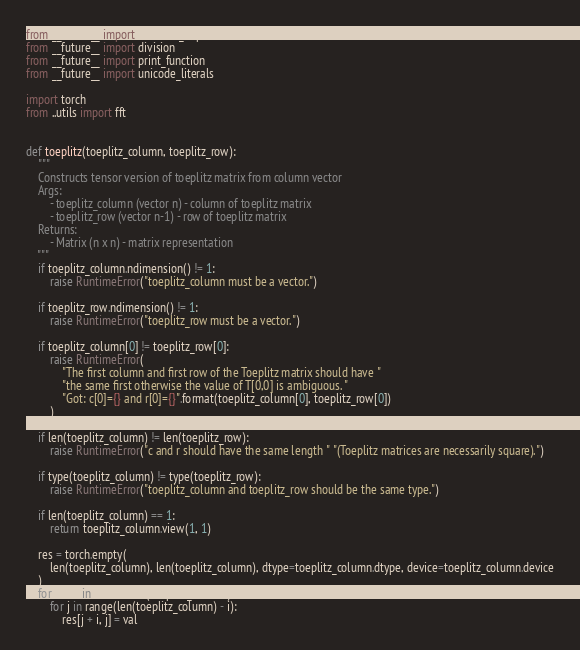<code> <loc_0><loc_0><loc_500><loc_500><_Python_>from __future__ import absolute_import
from __future__ import division
from __future__ import print_function
from __future__ import unicode_literals

import torch
from ..utils import fft


def toeplitz(toeplitz_column, toeplitz_row):
    """
    Constructs tensor version of toeplitz matrix from column vector
    Args:
        - toeplitz_column (vector n) - column of toeplitz matrix
        - toeplitz_row (vector n-1) - row of toeplitz matrix
    Returns:
        - Matrix (n x n) - matrix representation
    """
    if toeplitz_column.ndimension() != 1:
        raise RuntimeError("toeplitz_column must be a vector.")

    if toeplitz_row.ndimension() != 1:
        raise RuntimeError("toeplitz_row must be a vector.")

    if toeplitz_column[0] != toeplitz_row[0]:
        raise RuntimeError(
            "The first column and first row of the Toeplitz matrix should have "
            "the same first otherwise the value of T[0,0] is ambiguous. "
            "Got: c[0]={} and r[0]={}".format(toeplitz_column[0], toeplitz_row[0])
        )

    if len(toeplitz_column) != len(toeplitz_row):
        raise RuntimeError("c and r should have the same length " "(Toeplitz matrices are necessarily square).")

    if type(toeplitz_column) != type(toeplitz_row):
        raise RuntimeError("toeplitz_column and toeplitz_row should be the same type.")

    if len(toeplitz_column) == 1:
        return toeplitz_column.view(1, 1)

    res = torch.empty(
        len(toeplitz_column), len(toeplitz_column), dtype=toeplitz_column.dtype, device=toeplitz_column.device
    )
    for i, val in enumerate(toeplitz_column):
        for j in range(len(toeplitz_column) - i):
            res[j + i, j] = val</code> 